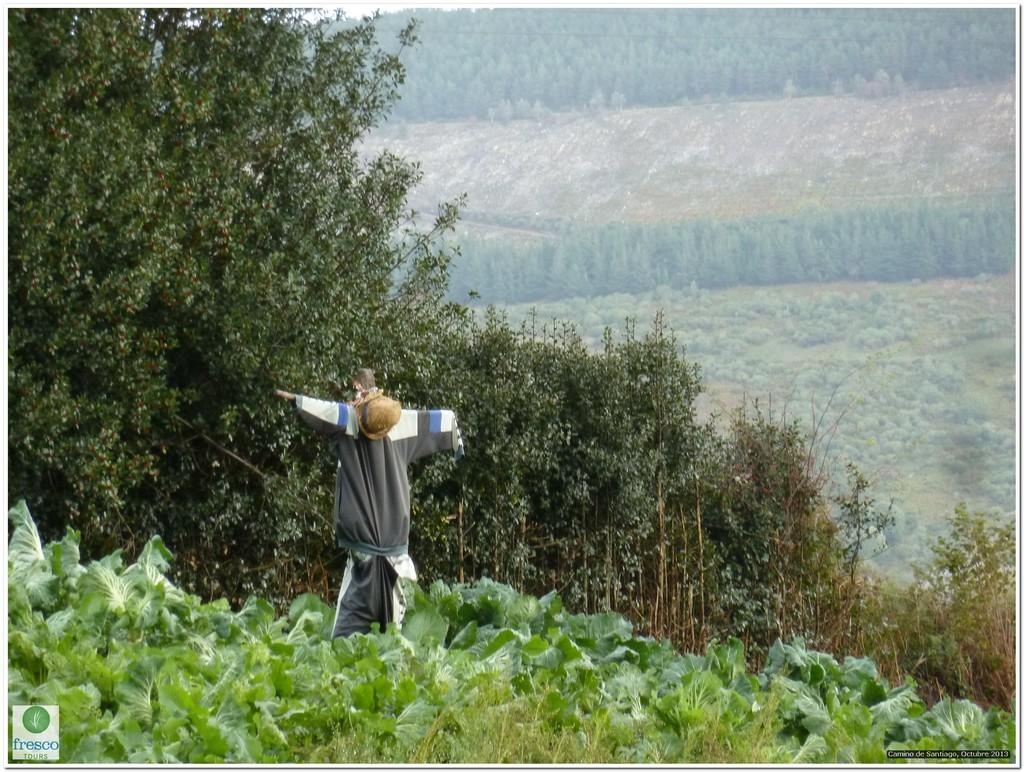What is located in the center of the image? There are clothes in the center of the image, and a hat is on some object there. Can you describe the logo in the image? The logo is located at the bottom left side of the image. What can be seen in the background of the image? There are trees and plants in the background of the image. What type of dress is being worn in the image? There is no dress visible in the image. 